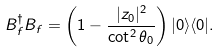Convert formula to latex. <formula><loc_0><loc_0><loc_500><loc_500>B _ { f } ^ { \dagger } B _ { f } = \left ( 1 - \frac { | z _ { 0 } | ^ { 2 } } { \cot ^ { 2 } \theta _ { 0 } } \right ) | 0 \rangle \langle 0 | .</formula> 